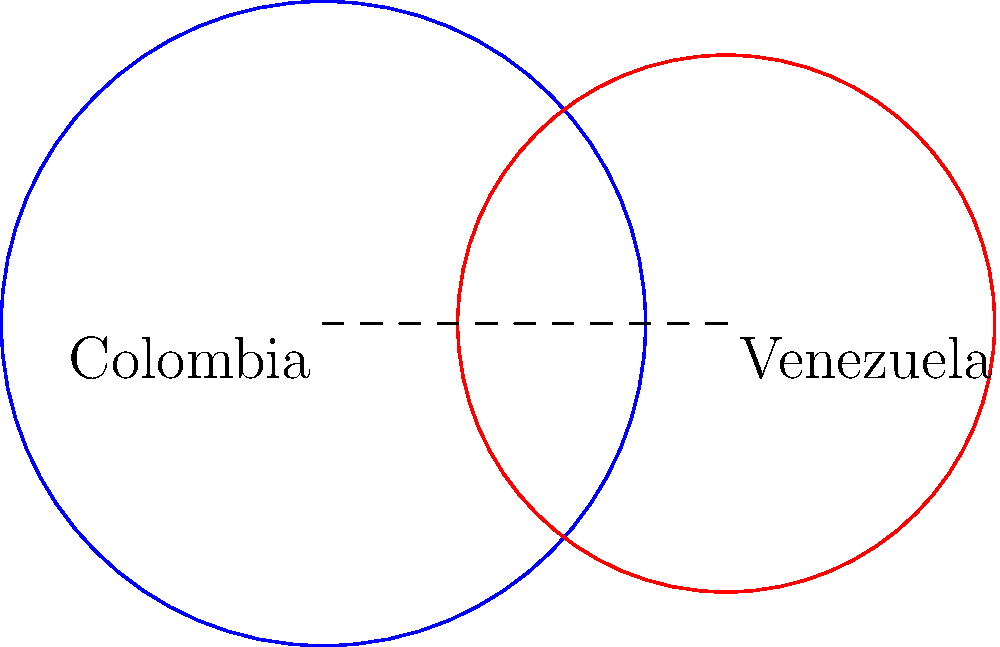In a cultural exchange analysis between Colombia and Venezuela, two overlapping circles represent the cultural influence of each country. The circle representing Colombia has a radius of 1.2 units, while Venezuela's circle has a radius of 1 unit. If the centers of the circles are 1.5 units apart, calculate the area of the overlapping region, which represents shared cultural elements. Round your answer to two decimal places. To find the area of the overlapping region between two circles, we need to use the formula for the area of intersection of two circles:

1. First, calculate the distance $d$ between the centers of the circles:
   $d = 1.5$ units (given in the question)

2. Let $r_1 = 1.2$ (radius of Colombia's circle) and $r_2 = 1$ (radius of Venezuela's circle)

3. Calculate the angles $\theta_1$ and $\theta_2$ using the law of cosines:

   $\theta_1 = 2 \arccos(\frac{d^2 + r_1^2 - r_2^2}{2dr_1})$
   $\theta_2 = 2 \arccos(\frac{d^2 + r_2^2 - r_1^2}{2dr_2})$

4. Calculate the area of intersection using the formula:

   $A = r_1^2 \arccos(\frac{d^2 + r_1^2 - r_2^2}{2dr_1}) + r_2^2 \arccos(\frac{d^2 + r_2^2 - r_1^2}{2dr_2}) - \frac{1}{2}\sqrt{(-d+r_1+r_2)(d+r_1-r_2)(d-r_1+r_2)(d+r_1+r_2)}$

5. Plug in the values:

   $A = 1.2^2 \arccos(\frac{1.5^2 + 1.2^2 - 1^2}{2 \cdot 1.5 \cdot 1.2}) + 1^2 \arccos(\frac{1.5^2 + 1^2 - 1.2^2}{2 \cdot 1.5 \cdot 1}) - \frac{1}{2}\sqrt{(-1.5+1.2+1)(1.5+1.2-1)(1.5-1.2+1)(1.5+1.2+1)}$

6. Calculate the result and round to two decimal places:

   $A \approx 0.81$ square units
Answer: 0.81 square units 